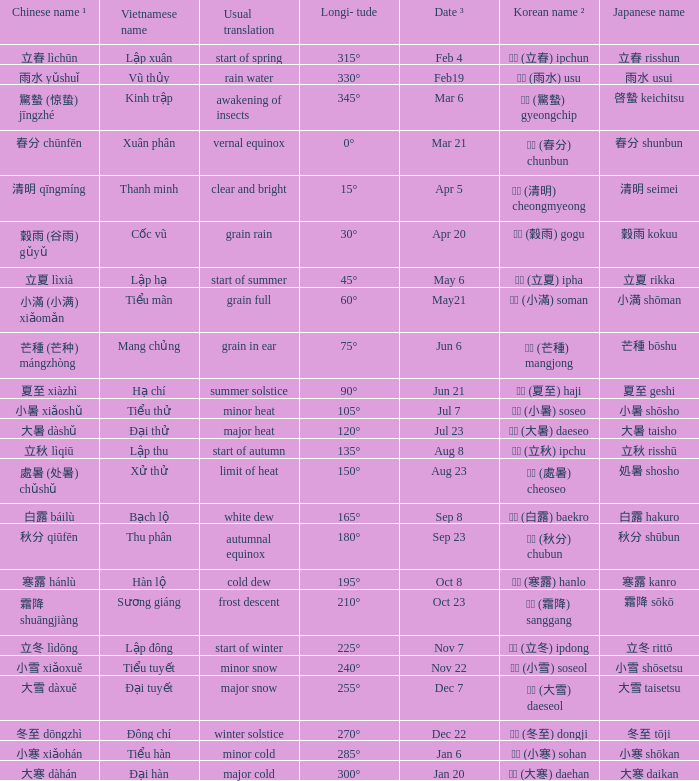Which Japanese name has a Korean name ² of 경칩 (驚蟄) gyeongchip? 啓蟄 keichitsu. 